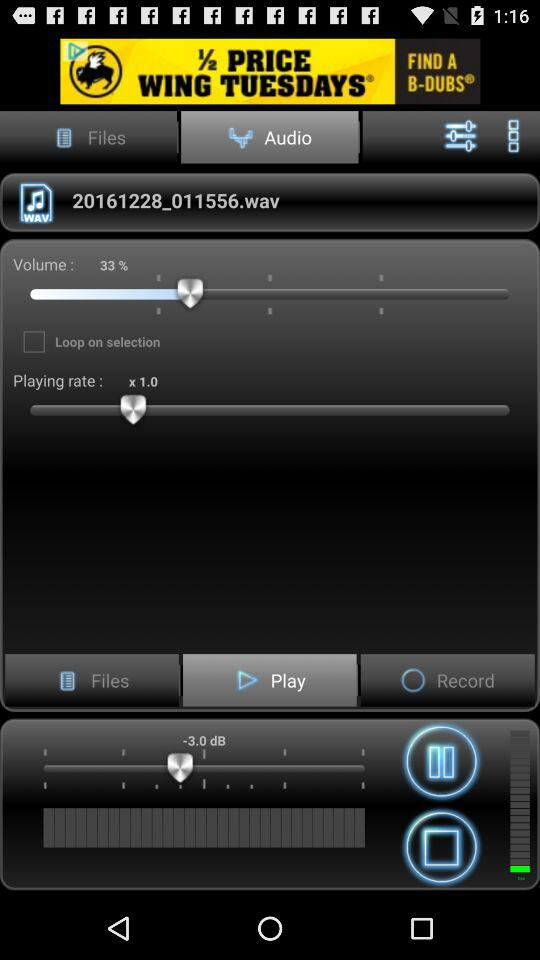Which tab is selected at the top? The selected tab at the top is "Audio". 